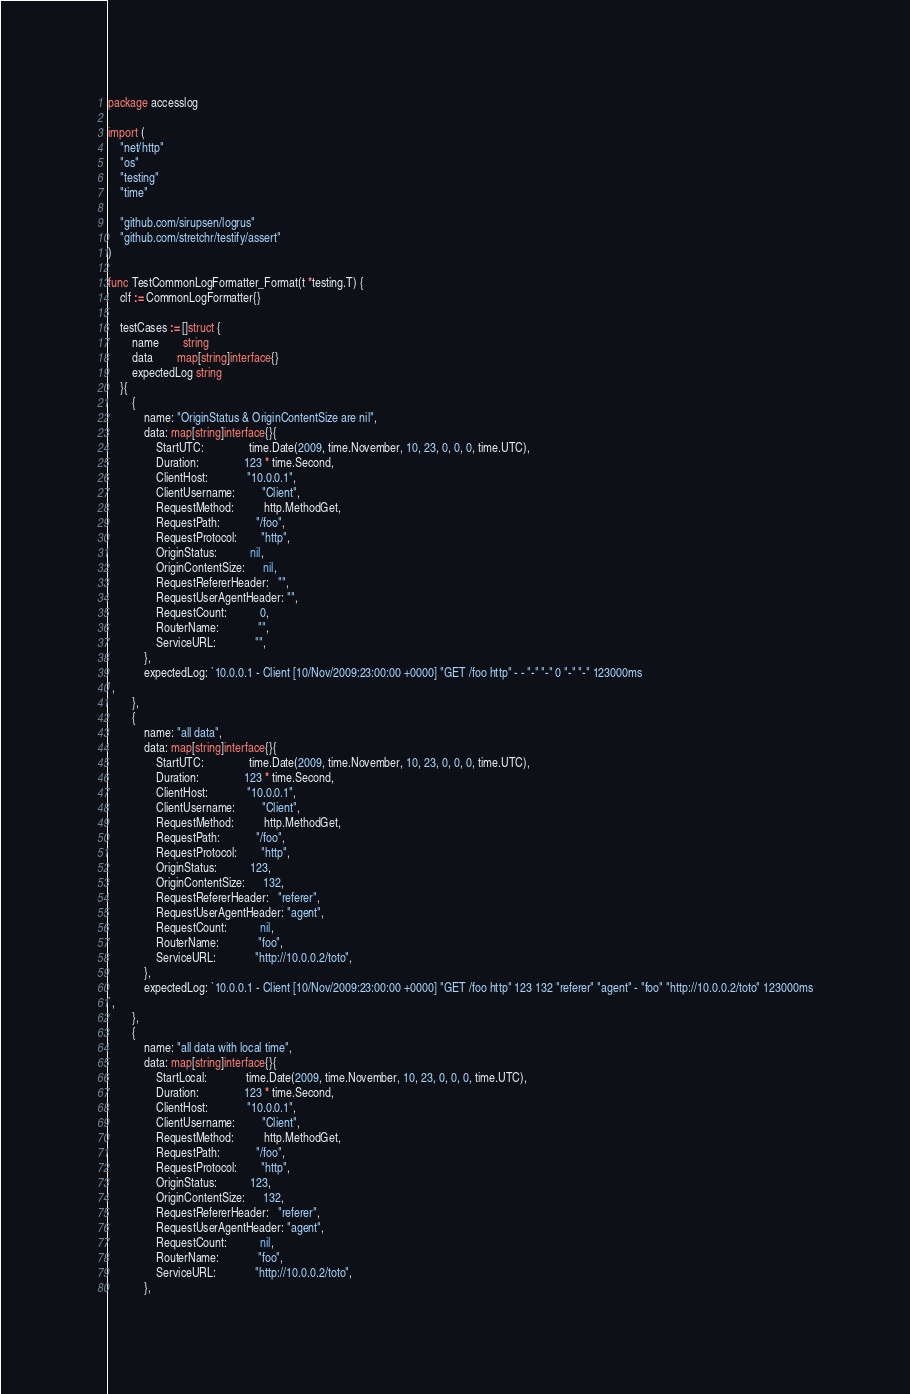<code> <loc_0><loc_0><loc_500><loc_500><_Go_>package accesslog

import (
	"net/http"
	"os"
	"testing"
	"time"

	"github.com/sirupsen/logrus"
	"github.com/stretchr/testify/assert"
)

func TestCommonLogFormatter_Format(t *testing.T) {
	clf := CommonLogFormatter{}

	testCases := []struct {
		name        string
		data        map[string]interface{}
		expectedLog string
	}{
		{
			name: "OriginStatus & OriginContentSize are nil",
			data: map[string]interface{}{
				StartUTC:               time.Date(2009, time.November, 10, 23, 0, 0, 0, time.UTC),
				Duration:               123 * time.Second,
				ClientHost:             "10.0.0.1",
				ClientUsername:         "Client",
				RequestMethod:          http.MethodGet,
				RequestPath:            "/foo",
				RequestProtocol:        "http",
				OriginStatus:           nil,
				OriginContentSize:      nil,
				RequestRefererHeader:   "",
				RequestUserAgentHeader: "",
				RequestCount:           0,
				RouterName:             "",
				ServiceURL:             "",
			},
			expectedLog: `10.0.0.1 - Client [10/Nov/2009:23:00:00 +0000] "GET /foo http" - - "-" "-" 0 "-" "-" 123000ms
`,
		},
		{
			name: "all data",
			data: map[string]interface{}{
				StartUTC:               time.Date(2009, time.November, 10, 23, 0, 0, 0, time.UTC),
				Duration:               123 * time.Second,
				ClientHost:             "10.0.0.1",
				ClientUsername:         "Client",
				RequestMethod:          http.MethodGet,
				RequestPath:            "/foo",
				RequestProtocol:        "http",
				OriginStatus:           123,
				OriginContentSize:      132,
				RequestRefererHeader:   "referer",
				RequestUserAgentHeader: "agent",
				RequestCount:           nil,
				RouterName:             "foo",
				ServiceURL:             "http://10.0.0.2/toto",
			},
			expectedLog: `10.0.0.1 - Client [10/Nov/2009:23:00:00 +0000] "GET /foo http" 123 132 "referer" "agent" - "foo" "http://10.0.0.2/toto" 123000ms
`,
		},
		{
			name: "all data with local time",
			data: map[string]interface{}{
				StartLocal:             time.Date(2009, time.November, 10, 23, 0, 0, 0, time.UTC),
				Duration:               123 * time.Second,
				ClientHost:             "10.0.0.1",
				ClientUsername:         "Client",
				RequestMethod:          http.MethodGet,
				RequestPath:            "/foo",
				RequestProtocol:        "http",
				OriginStatus:           123,
				OriginContentSize:      132,
				RequestRefererHeader:   "referer",
				RequestUserAgentHeader: "agent",
				RequestCount:           nil,
				RouterName:             "foo",
				ServiceURL:             "http://10.0.0.2/toto",
			},</code> 